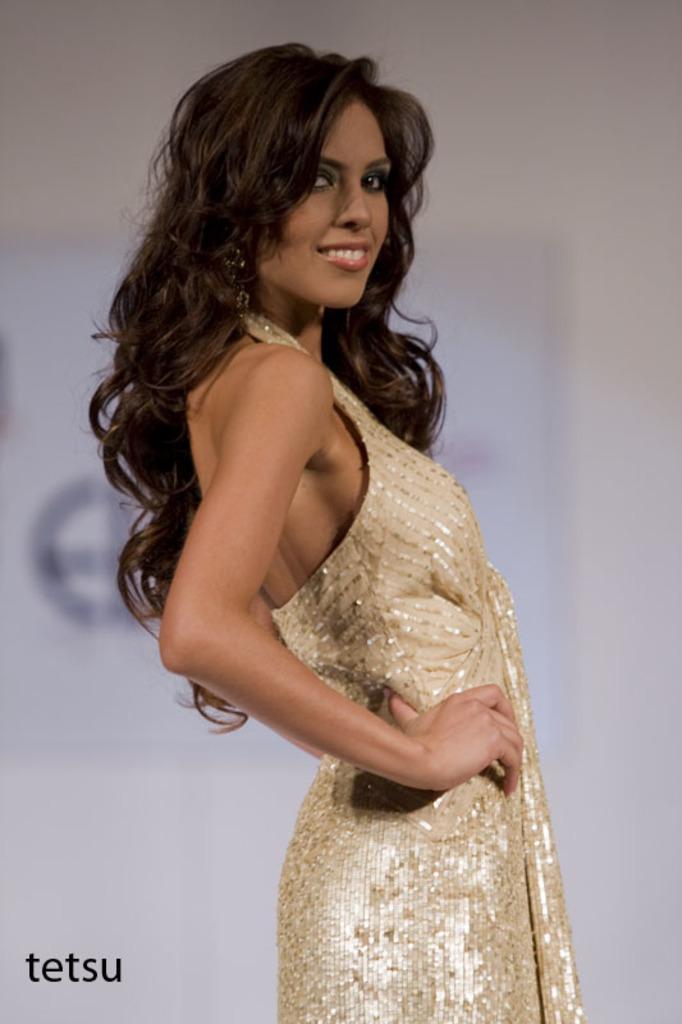Could you give a brief overview of what you see in this image? In this image, we can see a woman standing, in the background we can see a poster on the wall. 